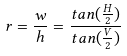<formula> <loc_0><loc_0><loc_500><loc_500>r = \frac { w } { h } = \frac { t a n ( \frac { H } { 2 } ) } { t a n ( \frac { V } { 2 } ) }</formula> 